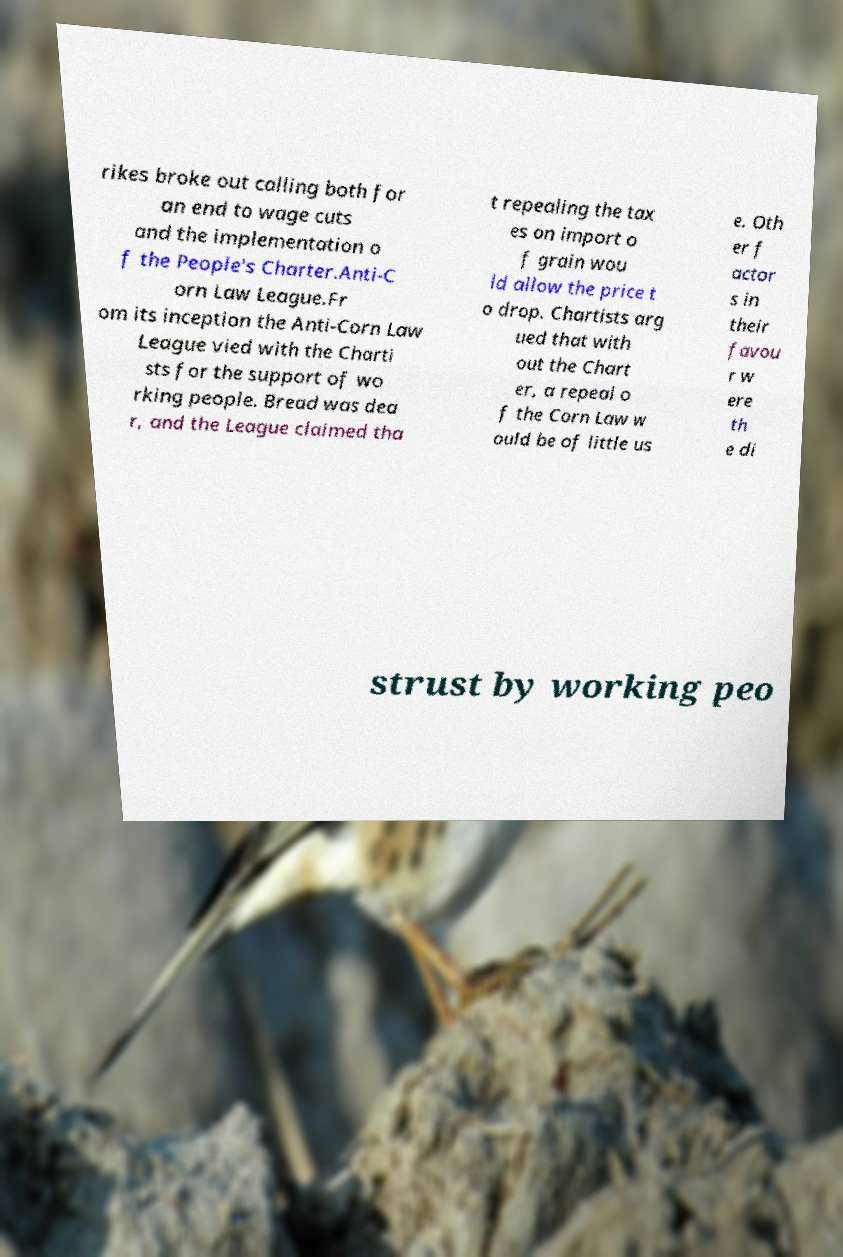Please read and relay the text visible in this image. What does it say? rikes broke out calling both for an end to wage cuts and the implementation o f the People's Charter.Anti-C orn Law League.Fr om its inception the Anti-Corn Law League vied with the Charti sts for the support of wo rking people. Bread was dea r, and the League claimed tha t repealing the tax es on import o f grain wou ld allow the price t o drop. Chartists arg ued that with out the Chart er, a repeal o f the Corn Law w ould be of little us e. Oth er f actor s in their favou r w ere th e di strust by working peo 